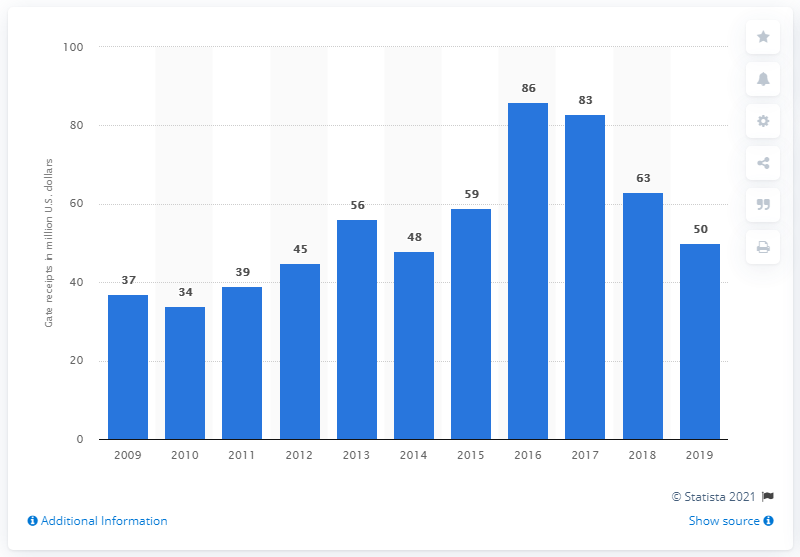Outline some significant characteristics in this image. In 2019, the Toronto Blue Jays' gate receipts totaled approximately 50 dollars. 